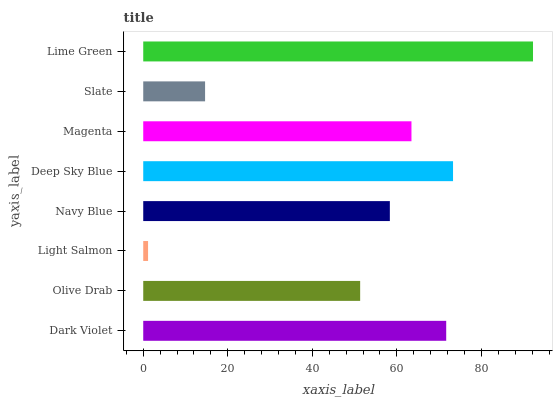Is Light Salmon the minimum?
Answer yes or no. Yes. Is Lime Green the maximum?
Answer yes or no. Yes. Is Olive Drab the minimum?
Answer yes or no. No. Is Olive Drab the maximum?
Answer yes or no. No. Is Dark Violet greater than Olive Drab?
Answer yes or no. Yes. Is Olive Drab less than Dark Violet?
Answer yes or no. Yes. Is Olive Drab greater than Dark Violet?
Answer yes or no. No. Is Dark Violet less than Olive Drab?
Answer yes or no. No. Is Magenta the high median?
Answer yes or no. Yes. Is Navy Blue the low median?
Answer yes or no. Yes. Is Light Salmon the high median?
Answer yes or no. No. Is Magenta the low median?
Answer yes or no. No. 